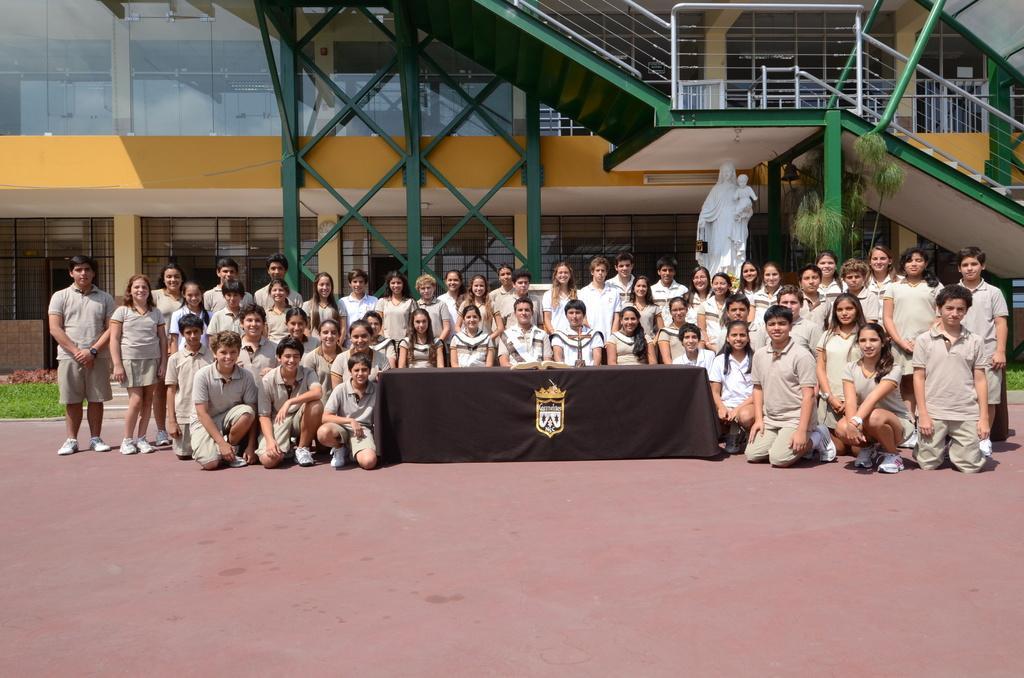Could you give a brief overview of what you see in this image? In this picture we can see a group of people on the ground and in the background we can see a building,statue. 